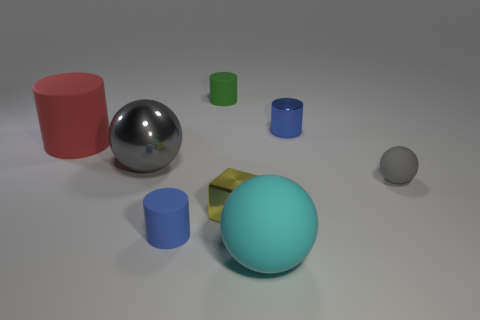Is there any other thing that has the same shape as the yellow object?
Your answer should be compact. No. How many things are either green rubber objects on the right side of the big gray metal object or metal objects that are behind the big matte cylinder?
Offer a terse response. 2. What size is the sphere that is the same material as the small cube?
Offer a very short reply. Large. How many metal objects are either tiny yellow cylinders or big red cylinders?
Make the answer very short. 0. How big is the gray metallic thing?
Offer a terse response. Large. Does the metallic block have the same size as the cyan rubber ball?
Make the answer very short. No. There is a gray thing to the right of the large cyan matte sphere; what is its material?
Your answer should be very brief. Rubber. What is the material of the big cyan thing that is the same shape as the tiny gray object?
Your answer should be compact. Rubber. Is there a blue object that is on the left side of the tiny matte cylinder that is in front of the large red object?
Offer a terse response. No. Do the blue metal object and the large red matte thing have the same shape?
Offer a very short reply. Yes. 